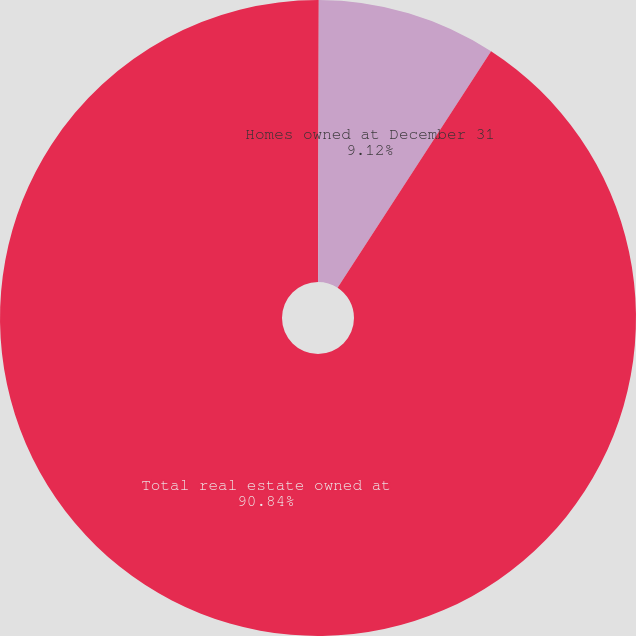Convert chart to OTSL. <chart><loc_0><loc_0><loc_500><loc_500><pie_chart><fcel>Homes acquired<fcel>Homes owned at December 31<fcel>Total real estate owned at<nl><fcel>0.04%<fcel>9.12%<fcel>90.84%<nl></chart> 